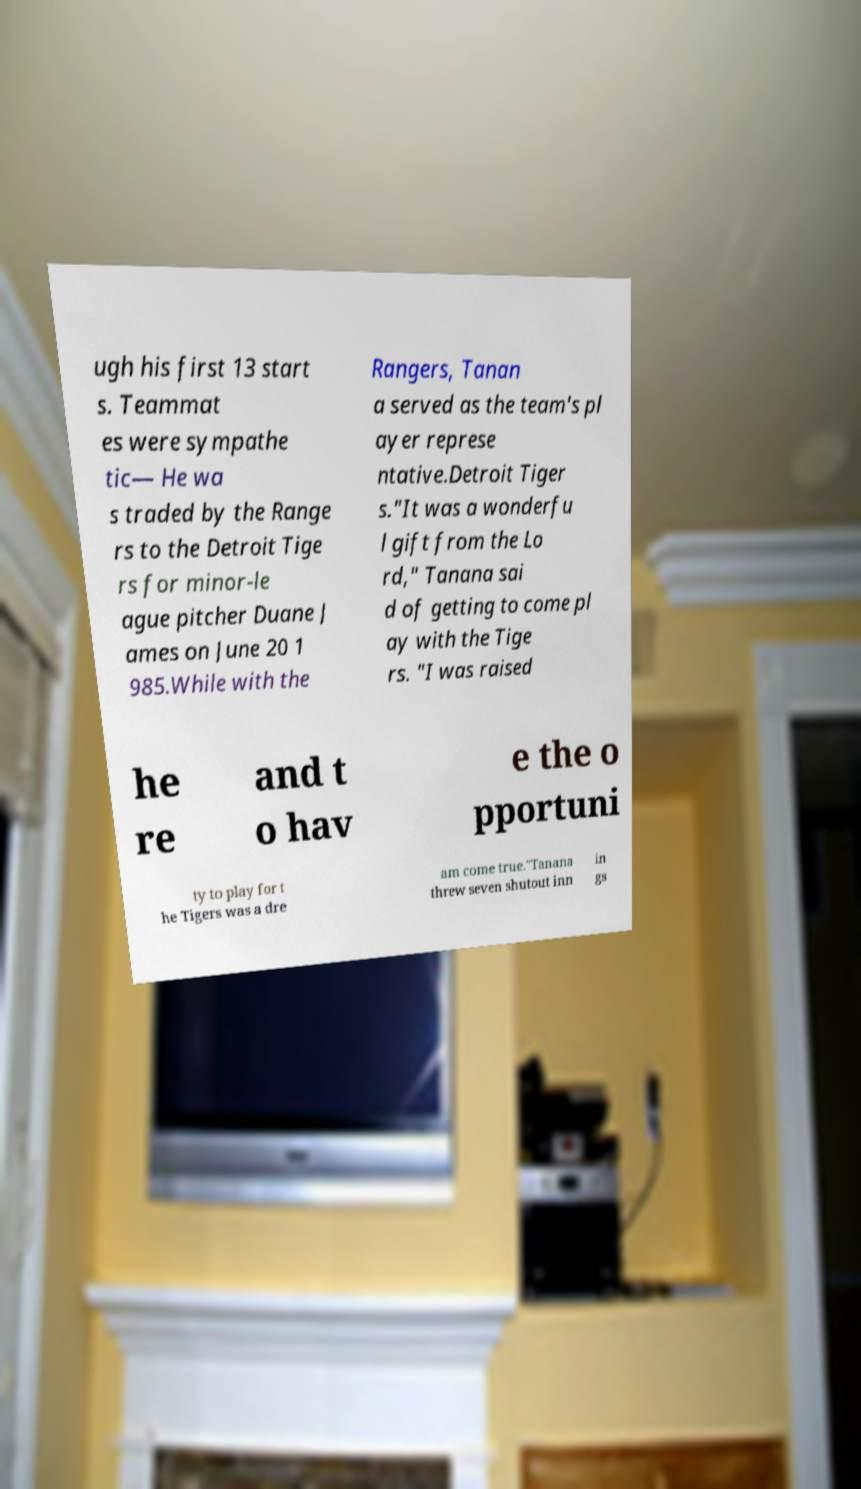For documentation purposes, I need the text within this image transcribed. Could you provide that? ugh his first 13 start s. Teammat es were sympathe tic— He wa s traded by the Range rs to the Detroit Tige rs for minor-le ague pitcher Duane J ames on June 20 1 985.While with the Rangers, Tanan a served as the team's pl ayer represe ntative.Detroit Tiger s."It was a wonderfu l gift from the Lo rd," Tanana sai d of getting to come pl ay with the Tige rs. "I was raised he re and t o hav e the o pportuni ty to play for t he Tigers was a dre am come true."Tanana threw seven shutout inn in gs 